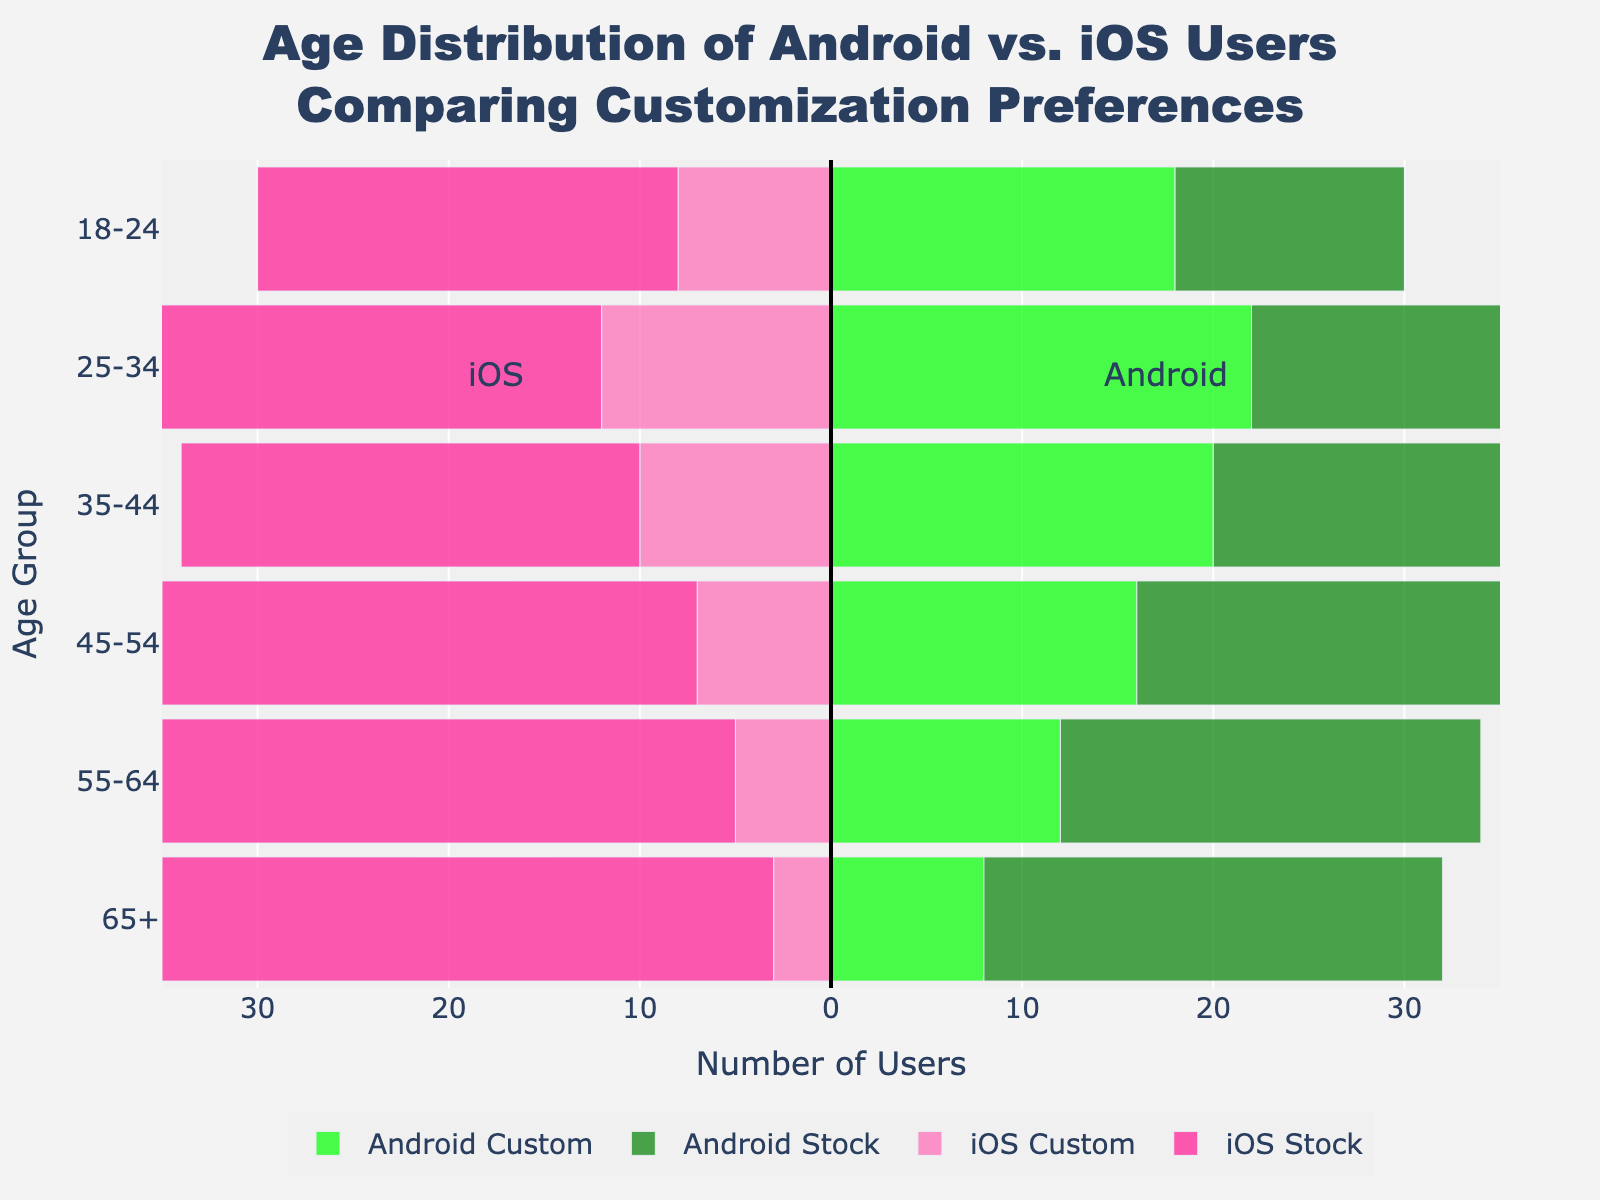what's the total number of users who prefer customized Android phones in the 25-34 age group? Look at the bar representing the customized Android preference for the 25-34 age group; the value is 22.
Answer: 22 Which age group has the highest number of iOS stock users? By comparing the lengths of the bars representing iOS stock usage, the longest bar corresponds to the age group 65+.
Answer: 65+ How does the number of customized iOS users compare to stock iOS users in the 45-54 age group? Compare the lengths of the bars for iOS Custom and iOS Stock in the 45-54 age group. iOS Custom has 7 while iOS Stock has 28.
Answer: iOS Stock users are more Which age group prefers customized Android phones the most? Look at the customized Android bars and find the highest value, which is in the 25-34 age group with a value of 22.
Answer: 25-34 What's the total number of users (custom and stock) in the 55-64 age group for both Android and iOS? Add the values for Android Custom (12), Android Stock (22), iOS Custom (5), and iOS Stock (30). 12 + 22 + 5 + 30 = 69
Answer: 69 Is there any age group where users prefer customized Android phones more than stock Android phones? Compare the lengths of the bars for Android Custom and Android Stock across all age groups. In the 18-24 and 25-34 age groups, the customized Android bars are longer (18 > 12 and 22 > 15 respectively).
Answer: Yes, in the 18-24 and 25-34 age groups What is the difference in the number of stock Android users between the 35-44 and 65+ age groups? Subtract the number of stock Android users in the 35-44 age group (18) from the number in the 65+ age group (24). 24 - 18 = 6
Answer: 6 In which age group is the disparity between customized and stock iOS users greatest? For each age group, subtract the number of customized iOS users from the number of stock iOS users, and identify the maximum difference: 22-8=14 (18-24), 26-12=14 (25-34), 24-10=14 (35-44), 28-7=21 (45-54), 30-5=25 (55-64), 32-3=29 (65+). The greatest disparity is in the 65+ age group with 29.
Answer: 65+ What's the total number of customized phone users (both Android and iOS) in the 35-44 age group? Add the values for customized Android (20) and customized iOS (10) in that age group. 20 + 10 = 30
Answer: 30 